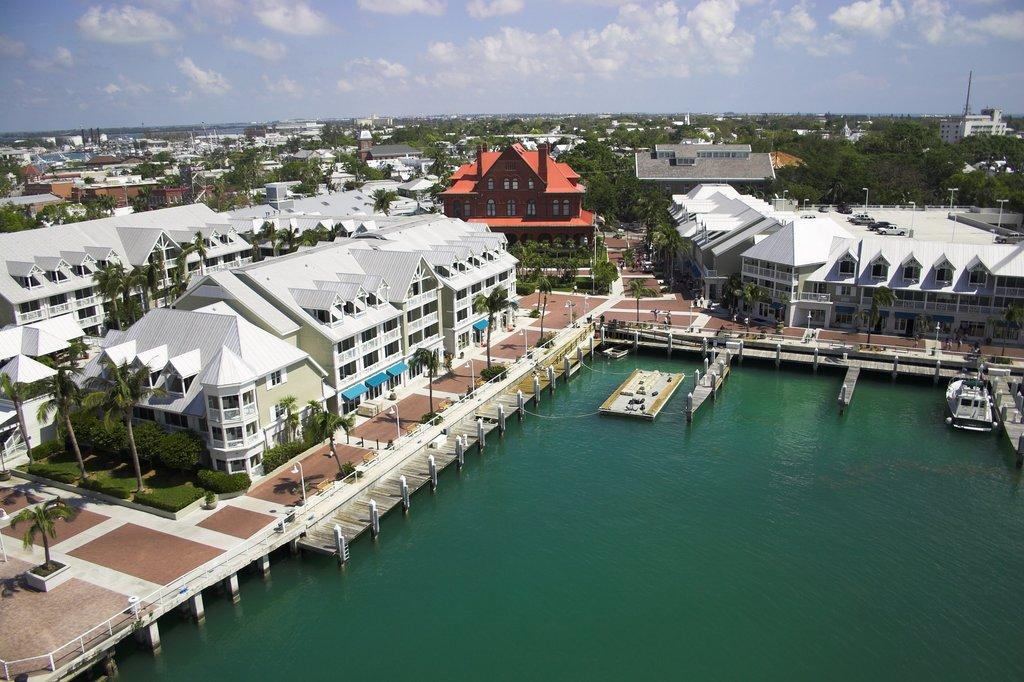What type of structures can be seen in the image? There are buildings in the image. What natural elements are present in the image? There are trees and plants in the image. What is the body of water in the image used for? There are boats on a lake in the image, suggesting that the lake is used for recreational activities. What architectural features can be seen in the image? There are windows and light poles in the image. What is the weather like in the image? The sky is cloudy in the image. Where is the cellar located in the image? There is no mention of a cellar in the image; it only features buildings, trees, plants, boats on a lake, windows, light poles, and a cloudy sky. What is the cannon used for in the image? There is no cannon present in the image. 